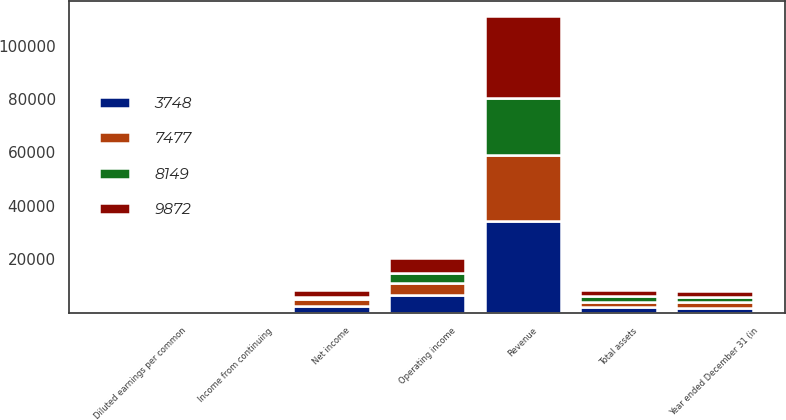Convert chart. <chart><loc_0><loc_0><loc_500><loc_500><stacked_bar_chart><ecel><fcel>Year ended December 31 (in<fcel>Revenue<fcel>Operating income<fcel>Income from continuing<fcel>Net income<fcel>Diluted earnings per common<fcel>Total assets<nl><fcel>3748<fcel>2008<fcel>34256<fcel>6732<fcel>0.87<fcel>2547<fcel>0.86<fcel>2121.5<nl><fcel>9872<fcel>2007<fcel>30895<fcel>5578<fcel>0.84<fcel>2587<fcel>0.83<fcel>2121.5<nl><fcel>7477<fcel>2006<fcel>24966<fcel>4619<fcel>0.71<fcel>2533<fcel>0.7<fcel>2121.5<nl><fcel>8149<fcel>2005<fcel>21075<fcel>3521<fcel>0.25<fcel>928<fcel>0.25<fcel>2121.5<nl></chart> 